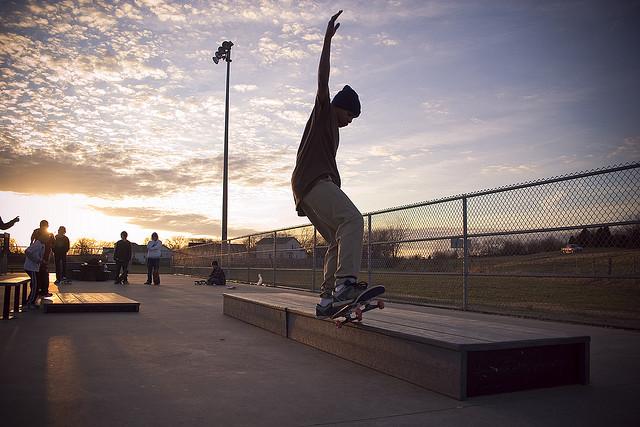What is the man riding on?
Be succinct. Skateboard. Are the lights on?
Be succinct. No. Is it day time?
Short answer required. Yes. 